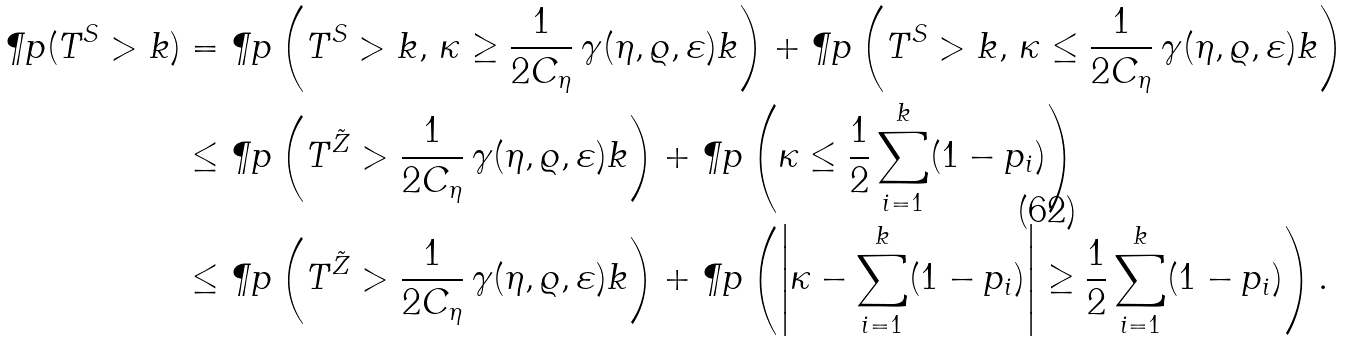<formula> <loc_0><loc_0><loc_500><loc_500>\P p ( T ^ { S } > k ) & = \P p \left ( T ^ { S } > k , \, \kappa \geq \frac { 1 } { 2 C _ { \eta } } \, \gamma ( \eta , \varrho , \varepsilon ) k \right ) + \P p \left ( T ^ { S } > k , \, \kappa \leq \frac { 1 } { 2 C _ { \eta } } \, \gamma ( \eta , \varrho , \varepsilon ) k \right ) \\ & \leq \P p \left ( T ^ { \tilde { Z } } > \frac { 1 } { 2 C _ { \eta } } \, \gamma ( \eta , \varrho , \varepsilon ) k \right ) + \P p \left ( \kappa \leq \frac { 1 } { 2 } \sum _ { i = 1 } ^ { k } ( 1 - p _ { i } ) \right ) \\ & \leq \P p \left ( T ^ { \tilde { Z } } > \frac { 1 } { 2 C _ { \eta } } \, \gamma ( \eta , \varrho , \varepsilon ) k \right ) + \P p \left ( \left | \kappa - \sum _ { i = 1 } ^ { k } ( 1 - p _ { i } ) \right | \geq \frac { 1 } { 2 } \sum _ { i = 1 } ^ { k } ( 1 - p _ { i } ) \right ) .</formula> 